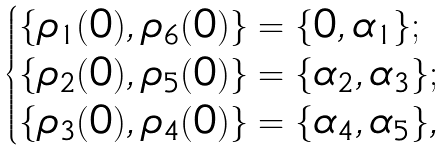<formula> <loc_0><loc_0><loc_500><loc_500>\begin{cases} \{ \rho _ { 1 } ( 0 ) , \rho _ { 6 } ( 0 ) \} = \{ 0 , \alpha _ { 1 } \} ; \\ \{ \rho _ { 2 } ( 0 ) , \rho _ { 5 } ( 0 ) \} = \{ \alpha _ { 2 } , \alpha _ { 3 } \} ; \\ \{ \rho _ { 3 } ( 0 ) , \rho _ { 4 } ( 0 ) \} = \{ \alpha _ { 4 } , \alpha _ { 5 } \} , \end{cases}</formula> 